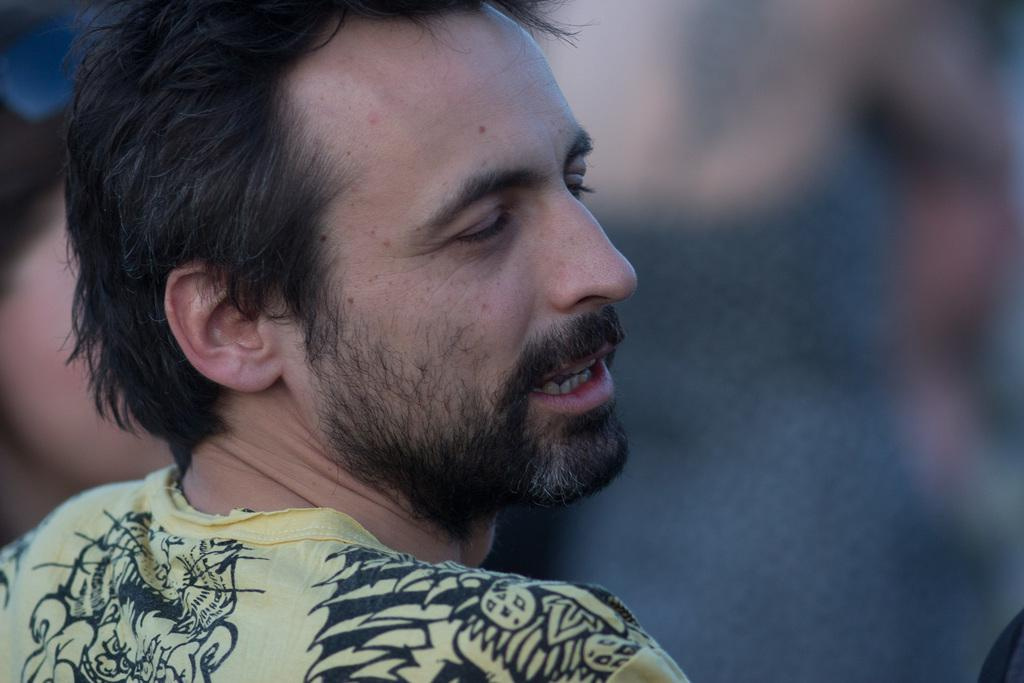What is the main subject in the foreground of the image? There is a man in the foreground of the image. Can you describe the man's facial hair? The man has a beard and mustache. What is the condition of the background in the image? The background of the image is blurry. What else can be seen in the background of the image? There are other objects visible in the background. What is the weight of the spark coming from the boats in the image? There are no boats or sparks present in the image, so it is not possible to determine their weight. 